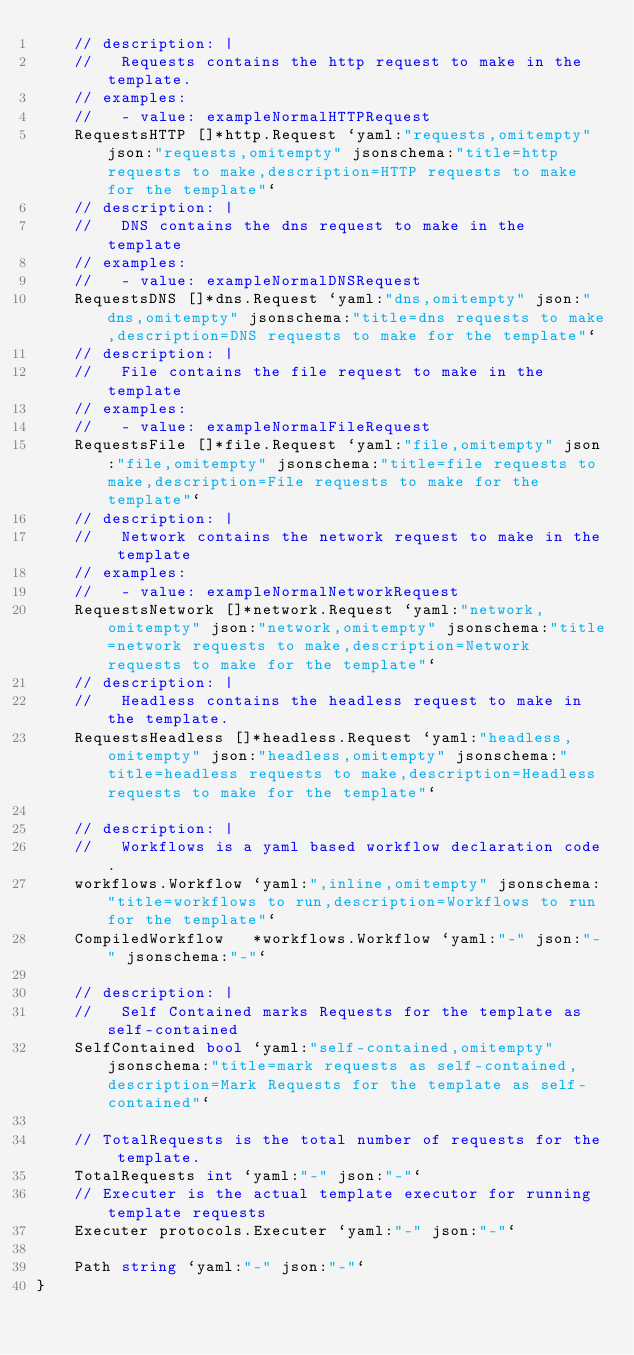Convert code to text. <code><loc_0><loc_0><loc_500><loc_500><_Go_>	// description: |
	//   Requests contains the http request to make in the template.
	// examples:
	//   - value: exampleNormalHTTPRequest
	RequestsHTTP []*http.Request `yaml:"requests,omitempty" json:"requests,omitempty" jsonschema:"title=http requests to make,description=HTTP requests to make for the template"`
	// description: |
	//   DNS contains the dns request to make in the template
	// examples:
	//   - value: exampleNormalDNSRequest
	RequestsDNS []*dns.Request `yaml:"dns,omitempty" json:"dns,omitempty" jsonschema:"title=dns requests to make,description=DNS requests to make for the template"`
	// description: |
	//   File contains the file request to make in the template
	// examples:
	//   - value: exampleNormalFileRequest
	RequestsFile []*file.Request `yaml:"file,omitempty" json:"file,omitempty" jsonschema:"title=file requests to make,description=File requests to make for the template"`
	// description: |
	//   Network contains the network request to make in the template
	// examples:
	//   - value: exampleNormalNetworkRequest
	RequestsNetwork []*network.Request `yaml:"network,omitempty" json:"network,omitempty" jsonschema:"title=network requests to make,description=Network requests to make for the template"`
	// description: |
	//   Headless contains the headless request to make in the template.
	RequestsHeadless []*headless.Request `yaml:"headless,omitempty" json:"headless,omitempty" jsonschema:"title=headless requests to make,description=Headless requests to make for the template"`

	// description: |
	//   Workflows is a yaml based workflow declaration code.
	workflows.Workflow `yaml:",inline,omitempty" jsonschema:"title=workflows to run,description=Workflows to run for the template"`
	CompiledWorkflow   *workflows.Workflow `yaml:"-" json:"-" jsonschema:"-"`

	// description: |
	//   Self Contained marks Requests for the template as self-contained
	SelfContained bool `yaml:"self-contained,omitempty" jsonschema:"title=mark requests as self-contained,description=Mark Requests for the template as self-contained"`

	// TotalRequests is the total number of requests for the template.
	TotalRequests int `yaml:"-" json:"-"`
	// Executer is the actual template executor for running template requests
	Executer protocols.Executer `yaml:"-" json:"-"`

	Path string `yaml:"-" json:"-"`
}
</code> 